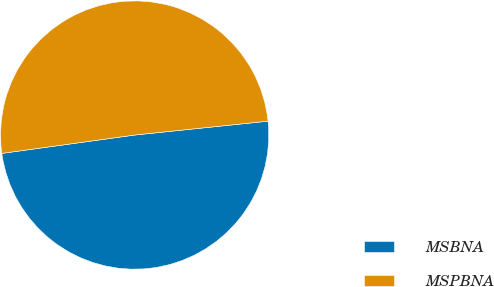Convert chart. <chart><loc_0><loc_0><loc_500><loc_500><pie_chart><fcel>MSBNA<fcel>MSPBNA<nl><fcel>49.46%<fcel>50.54%<nl></chart> 